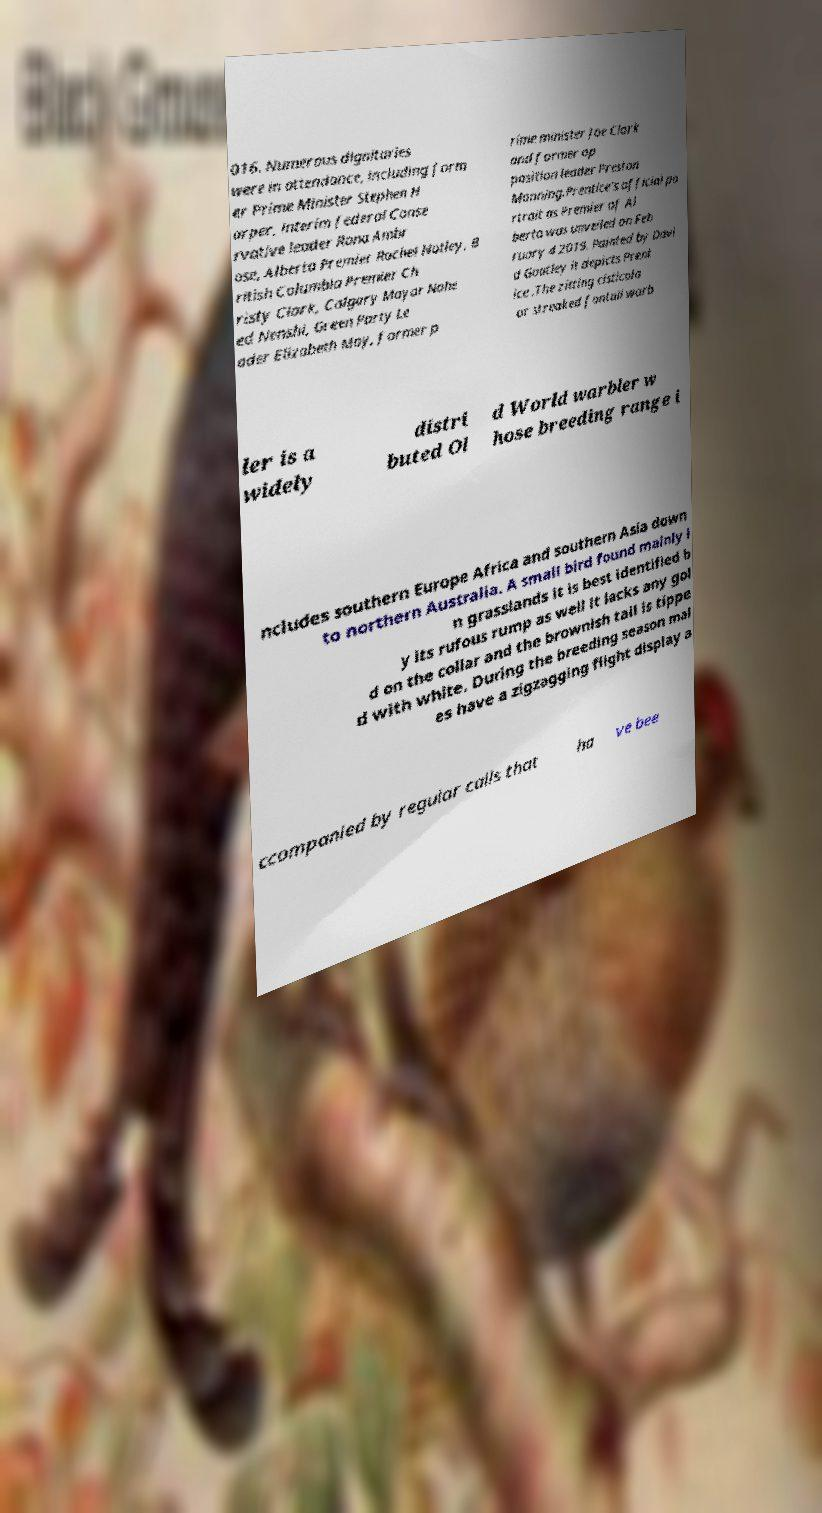For documentation purposes, I need the text within this image transcribed. Could you provide that? 016. Numerous dignitaries were in attendance, including form er Prime Minister Stephen H arper, interim federal Conse rvative leader Rona Ambr ose, Alberta Premier Rachel Notley, B ritish Columbia Premier Ch risty Clark, Calgary Mayor Nahe ed Nenshi, Green Party Le ader Elizabeth May, former p rime minister Joe Clark and former op position leader Preston Manning.Prentice's official po rtrait as Premier of Al berta was unveiled on Feb ruary 4 2019. Painted by Davi d Goatley it depicts Prent ice .The zitting cisticola or streaked fantail warb ler is a widely distri buted Ol d World warbler w hose breeding range i ncludes southern Europe Africa and southern Asia down to northern Australia. A small bird found mainly i n grasslands it is best identified b y its rufous rump as well it lacks any gol d on the collar and the brownish tail is tippe d with white. During the breeding season mal es have a zigzagging flight display a ccompanied by regular calls that ha ve bee 